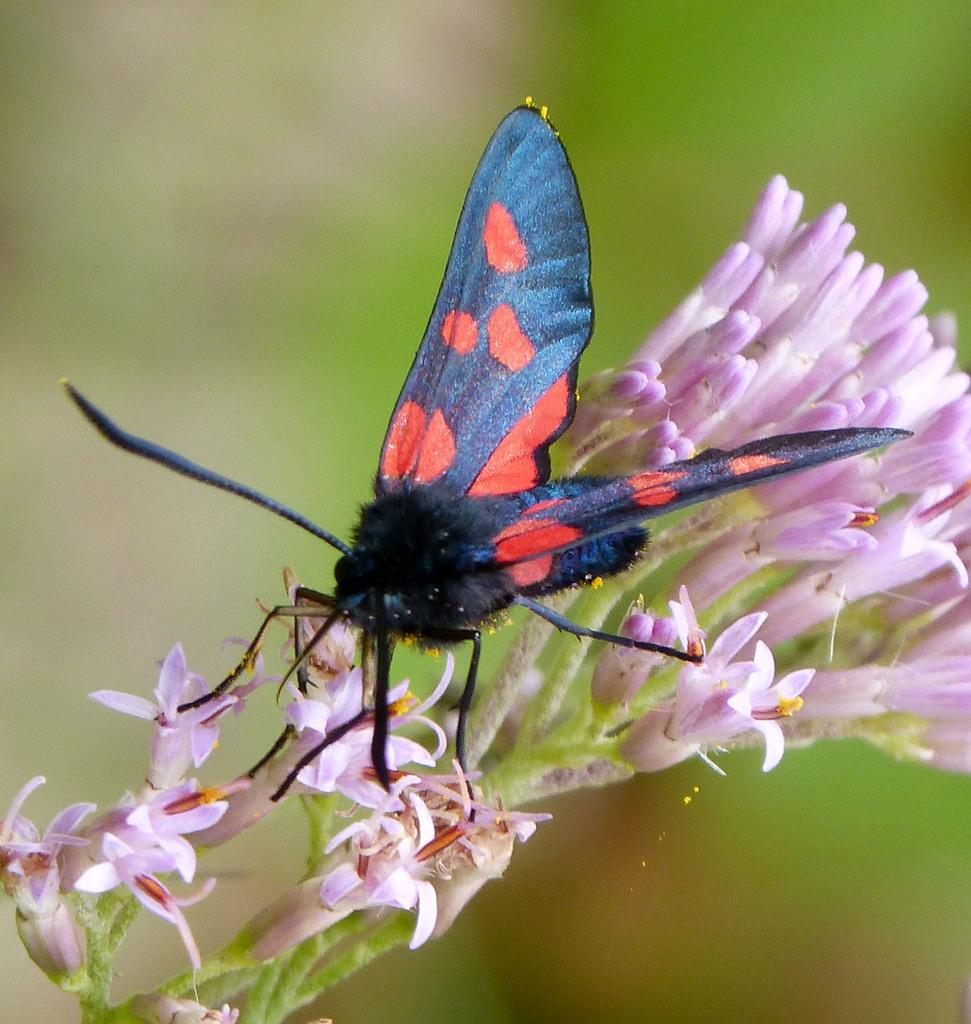What type of living organisms can be seen in the image? There are flowers and a butterfly in the image. What is the primary subject of the image? The primary subject of the image is the butterfly. Can you describe the background of the image? The background of the image is blurry. What type of alarm can be heard going off in the image? There is no alarm present in the image, as it is a photograph of flowers and a butterfly. What type of chalk is being used to draw on the butterfly in the image? There is no chalk or drawing present in the image; it is a photograph of flowers and a butterfly in their natural state. 